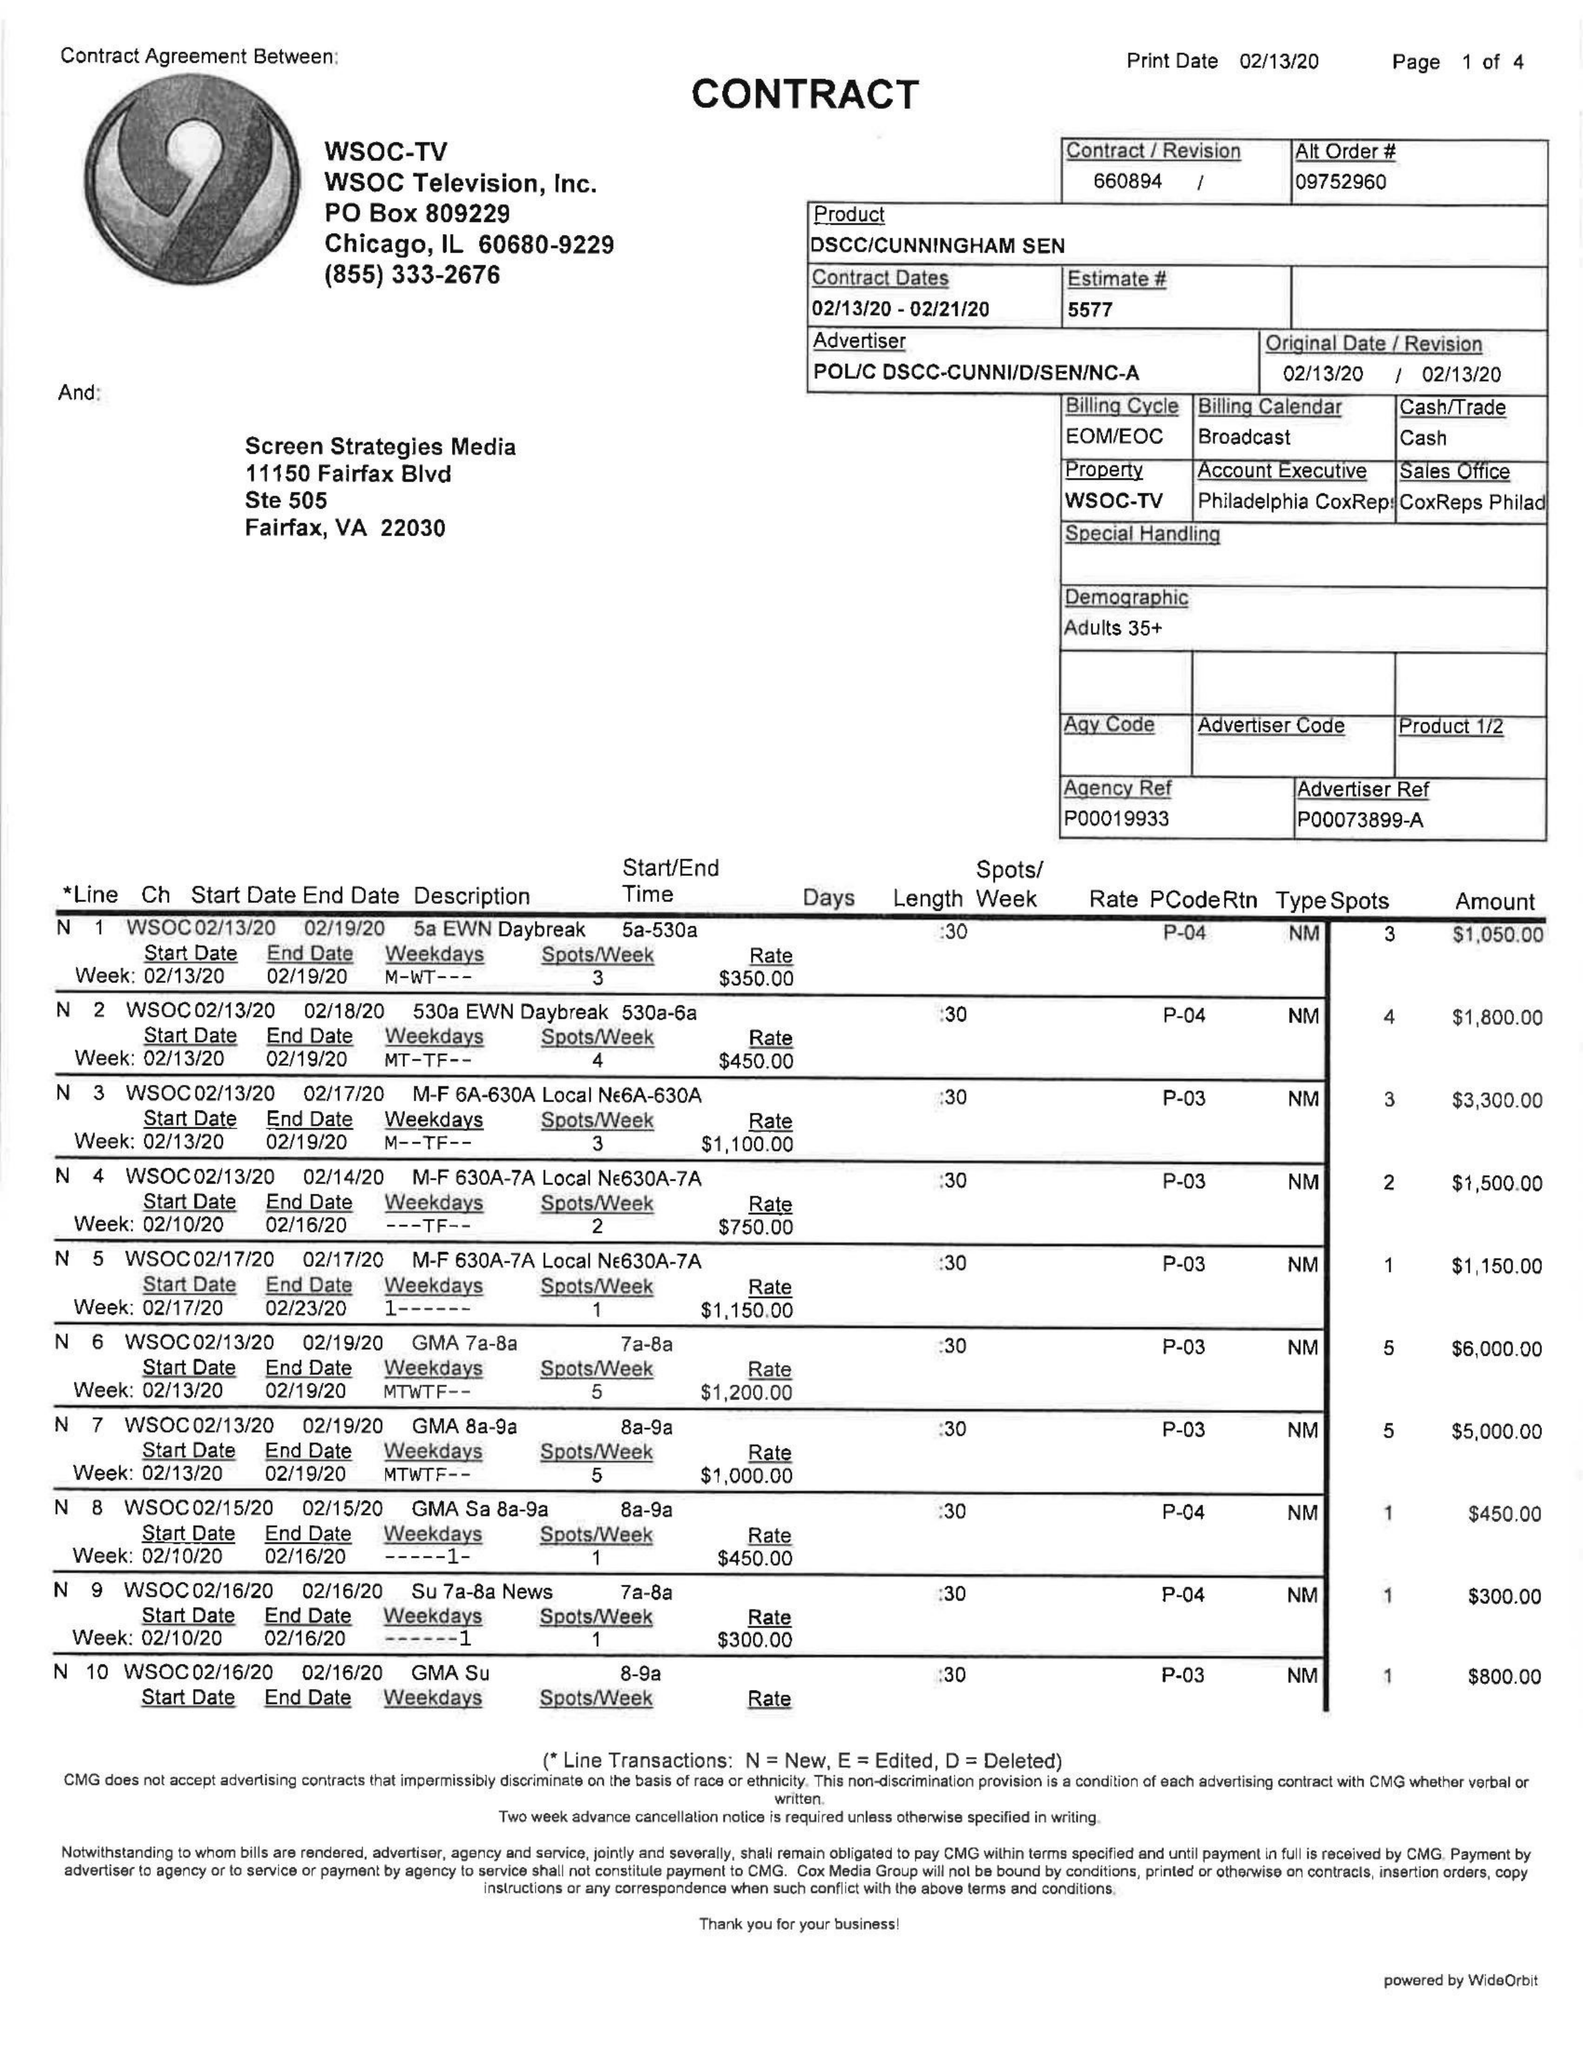What is the value for the contract_num?
Answer the question using a single word or phrase. 660894 